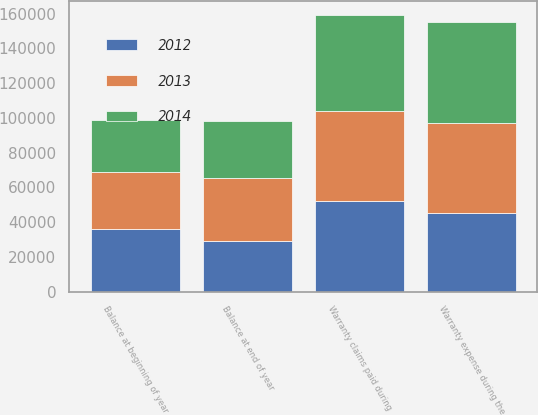Convert chart to OTSL. <chart><loc_0><loc_0><loc_500><loc_500><stacked_bar_chart><ecel><fcel>Balance at beginning of year<fcel>Warranty claims paid during<fcel>Warranty expense during the<fcel>Balance at end of year<nl><fcel>2012<fcel>35818<fcel>51941<fcel>45473<fcel>29350<nl><fcel>2013<fcel>32930<fcel>52011<fcel>51510<fcel>35818<nl><fcel>2014<fcel>30144<fcel>55314<fcel>58100<fcel>32930<nl></chart> 